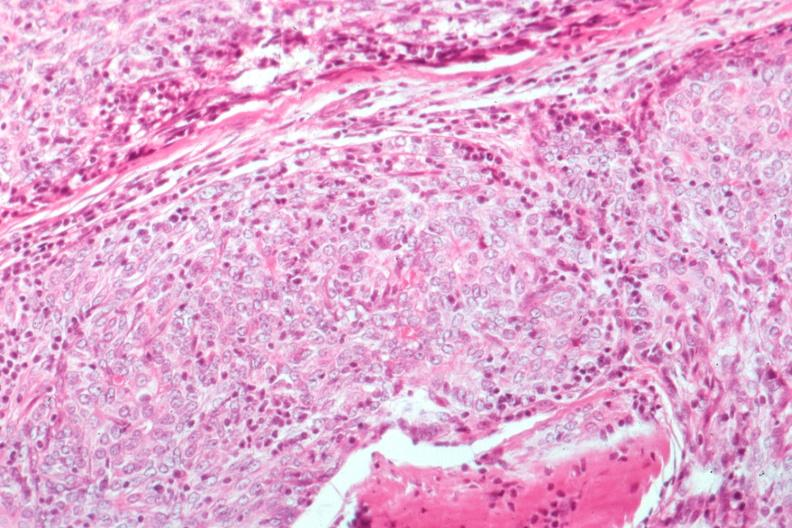does this image show epithelial lesion surgical path?
Answer the question using a single word or phrase. Yes 